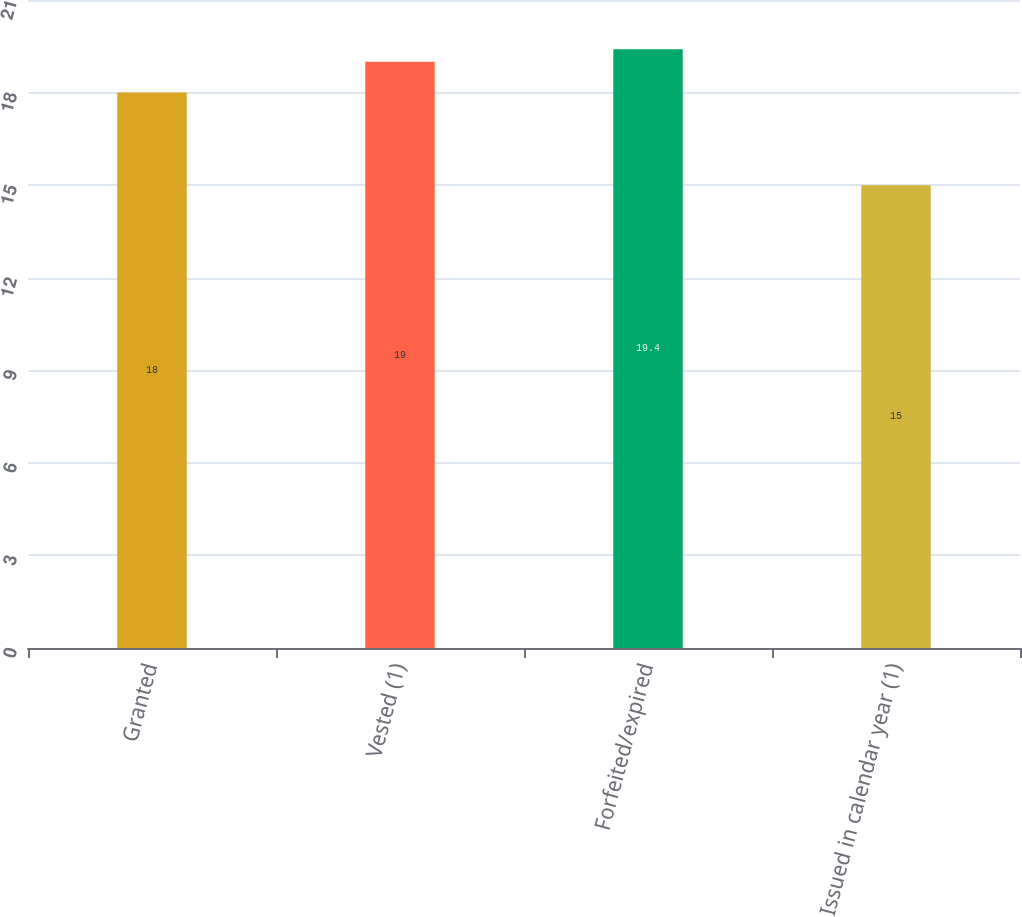Convert chart. <chart><loc_0><loc_0><loc_500><loc_500><bar_chart><fcel>Granted<fcel>Vested (1)<fcel>Forfeited/expired<fcel>Issued in calendar year (1)<nl><fcel>18<fcel>19<fcel>19.4<fcel>15<nl></chart> 